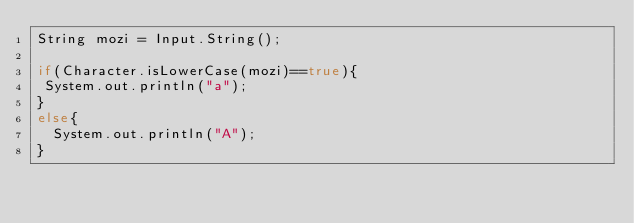Convert code to text. <code><loc_0><loc_0><loc_500><loc_500><_Java_>String mozi = Input.String();

if(Character.isLowerCase(mozi)==true){
 System.out.println("a");
}
else{
  System.out.println("A");
}
</code> 